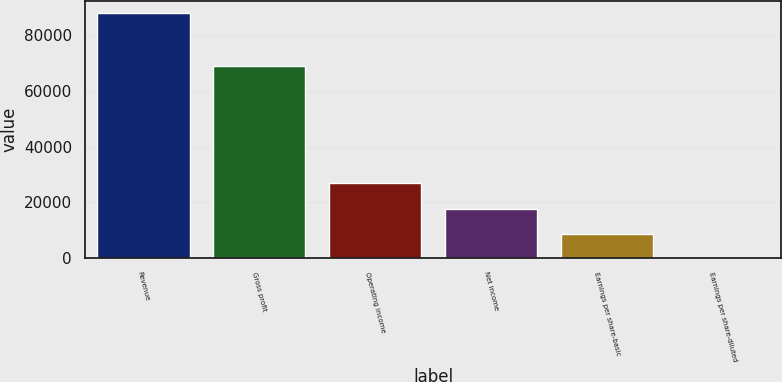Convert chart. <chart><loc_0><loc_0><loc_500><loc_500><bar_chart><fcel>Revenue<fcel>Gross profit<fcel>Operating income<fcel>Net income<fcel>Earnings per share-basic<fcel>Earnings per share-diluted<nl><fcel>87859<fcel>68979<fcel>26821<fcel>17572<fcel>8786.08<fcel>0.2<nl></chart> 